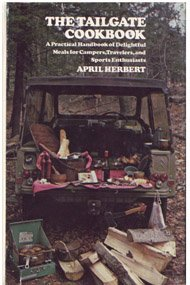What is the title of this book? The title of the book shown in the image is 'The Tailgate Cookbook,' a unique guide focusing on meals suited for tailgating. 